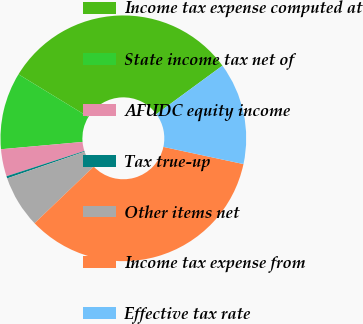<chart> <loc_0><loc_0><loc_500><loc_500><pie_chart><fcel>Income tax expense computed at<fcel>State income tax net of<fcel>AFUDC equity income<fcel>Tax true-up<fcel>Other items net<fcel>Income tax expense from<fcel>Effective tax rate<nl><fcel>31.21%<fcel>10.14%<fcel>3.58%<fcel>0.29%<fcel>6.86%<fcel>34.49%<fcel>13.43%<nl></chart> 